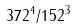Convert formula to latex. <formula><loc_0><loc_0><loc_500><loc_500>3 7 2 ^ { 4 } / 1 5 2 ^ { 3 }</formula> 